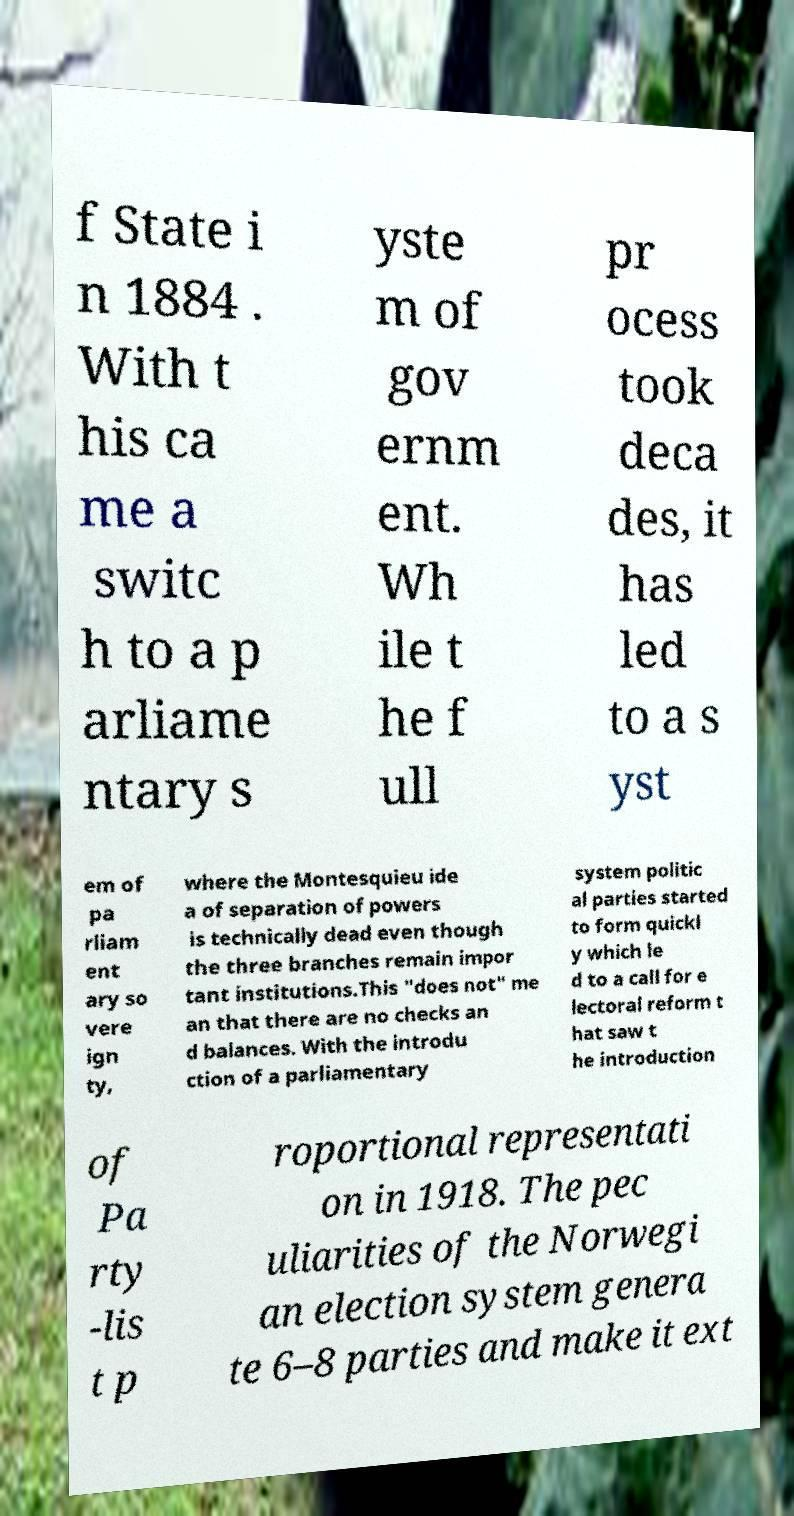What messages or text are displayed in this image? I need them in a readable, typed format. f State i n 1884 . With t his ca me a switc h to a p arliame ntary s yste m of gov ernm ent. Wh ile t he f ull pr ocess took deca des, it has led to a s yst em of pa rliam ent ary so vere ign ty, where the Montesquieu ide a of separation of powers is technically dead even though the three branches remain impor tant institutions.This "does not" me an that there are no checks an d balances. With the introdu ction of a parliamentary system politic al parties started to form quickl y which le d to a call for e lectoral reform t hat saw t he introduction of Pa rty -lis t p roportional representati on in 1918. The pec uliarities of the Norwegi an election system genera te 6–8 parties and make it ext 